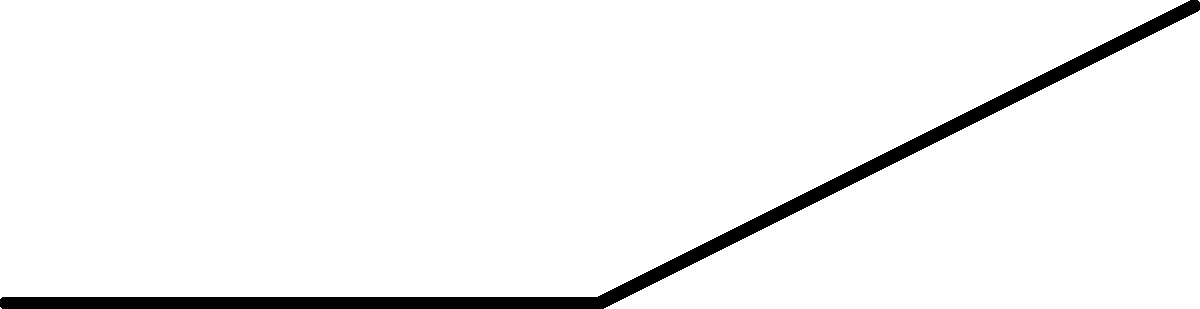In a bicep curl exercise, the weight force ($\vec{F}_w$) acts vertically downward at the hand, while the muscle force ($\vec{F}_m$) acts at an angle. If the forearm length is 30 cm and the weight is 20 kg, what is the magnitude of the torque generated by the biceps muscle about the elbow joint when the forearm is horizontal and the muscle force acts at a 45° angle to the forearm? To solve this problem, we'll follow these steps:

1) First, we need to calculate the weight force:
   $F_w = mg = 20 \text{ kg} \times 9.8 \text{ m/s}^2 = 196 \text{ N}$

2) The torque due to the weight force is:
   $\tau_w = F_w \times d = 196 \text{ N} \times 0.3 \text{ m} = 58.8 \text{ N·m}$

3) At equilibrium, the torque from the muscle force must equal this:
   $\tau_m = \tau_w = 58.8 \text{ N·m}$

4) The torque from the muscle force is given by:
   $\tau_m = F_m \times d \times \sin{\theta}$
   where $\theta$ is the angle between the force and the forearm (45°)

5) Rearranging to solve for $F_m$:
   $F_m = \frac{\tau_m}{d \times \sin{\theta}} = \frac{58.8 \text{ N·m}}{0.3 \text{ m} \times \sin{45°}}$

6) Calculating:
   $F_m = \frac{58.8}{0.3 \times 0.707} = 277.2 \text{ N}$

Therefore, the magnitude of the muscle force is approximately 277.2 N.
Answer: 277.2 N 